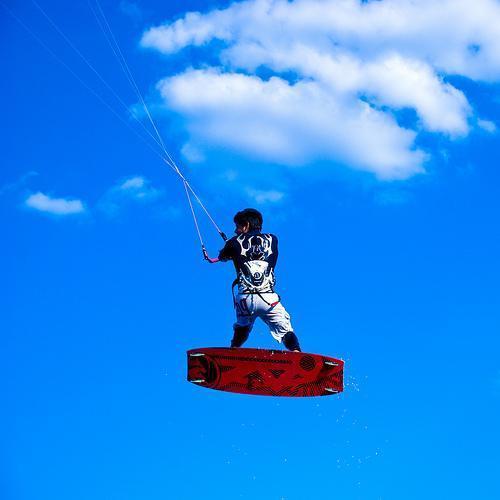How many people are in this picture?
Give a very brief answer. 1. How many people are on the board?
Give a very brief answer. 1. How many people are flying in the image?
Give a very brief answer. 1. 